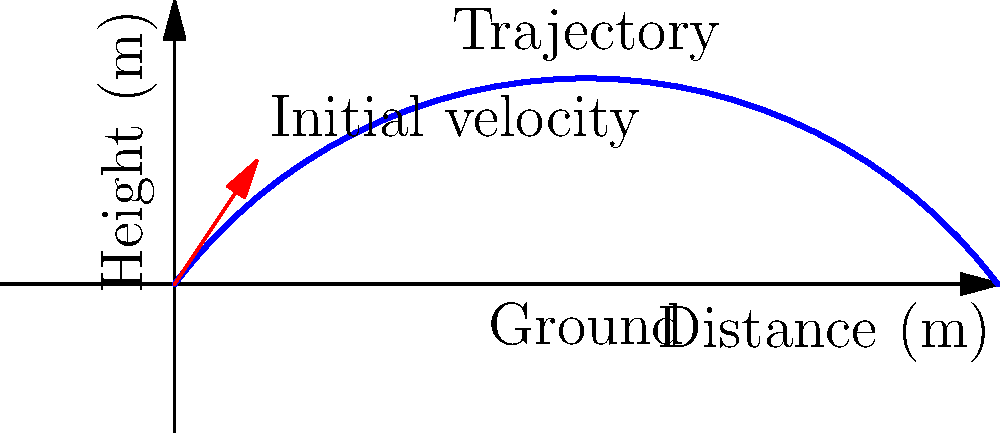In a rugby match, Makenzie is about to perform a kick. The diagram shows the trajectory of the ball and the initial force vector. If the ball's initial velocity is 20 m/s at an angle of 45° to the horizontal, and air resistance is negligible, what is the maximum height reached by the ball? To find the maximum height of the ball, we can follow these steps:

1. Identify the relevant equations:
   - Vertical motion: $y = v_0y \cdot t - \frac{1}{2}gt^2$
   - Time to reach maximum height: $t_{max} = \frac{v_0y}{g}$

2. Calculate the initial vertical velocity component:
   $v_0y = v_0 \sin{\theta} = 20 \cdot \sin{45°} = 20 \cdot \frac{\sqrt{2}}{2} \approx 14.14$ m/s

3. Calculate the time to reach maximum height:
   $t_{max} = \frac{v_0y}{g} = \frac{14.14}{9.8} \approx 1.44$ s

4. Calculate the maximum height:
   $h_{max} = v_0y \cdot t_{max} - \frac{1}{2}g \cdot t_{max}^2$
   $h_{max} = 14.14 \cdot 1.44 - \frac{1}{2} \cdot 9.8 \cdot 1.44^2$
   $h_{max} = 20.36 - 10.18 = 10.18$ m

Therefore, the maximum height reached by the ball is approximately 10.18 meters.
Answer: 10.18 m 